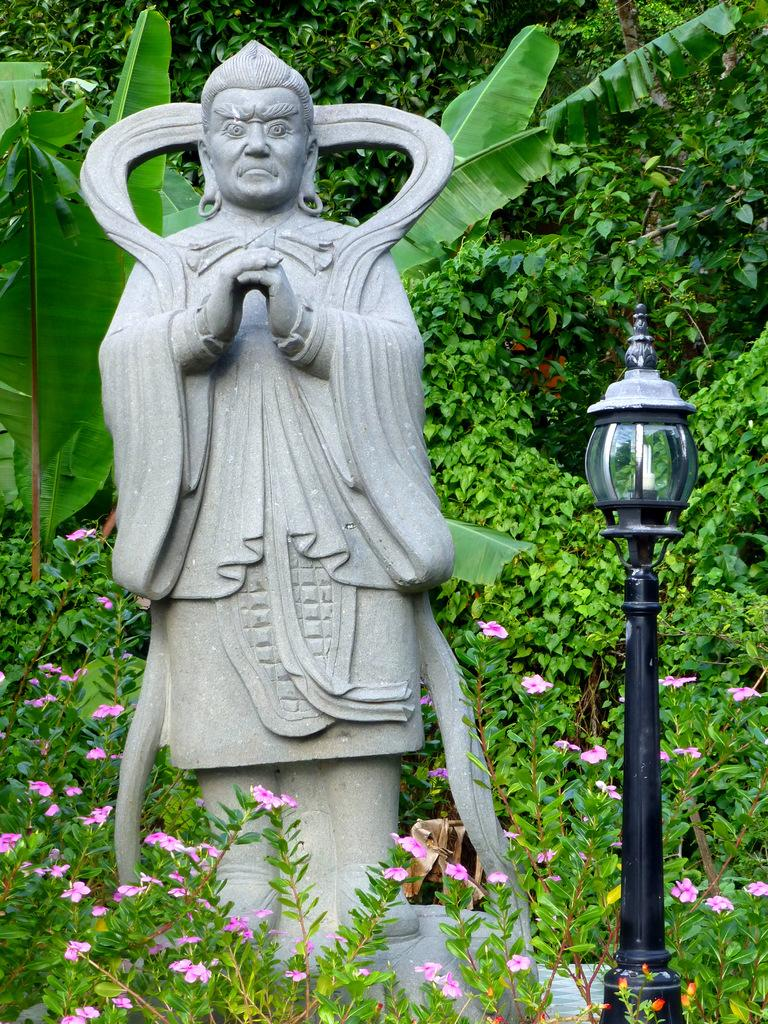What is the main subject in the image? There is a statue in the image. What can be seen illuminating the statue? There is a light in the image. What type of natural elements are present in the image? There are trees, plants, and flowers in the image. How many fingers can be seen on the statue's hand in the image? There is no visible hand or fingers on the statue in the image. What type of pot is being used to hold the flowers in the image? There is no pot visible in the image; the flowers are not contained in a pot. 